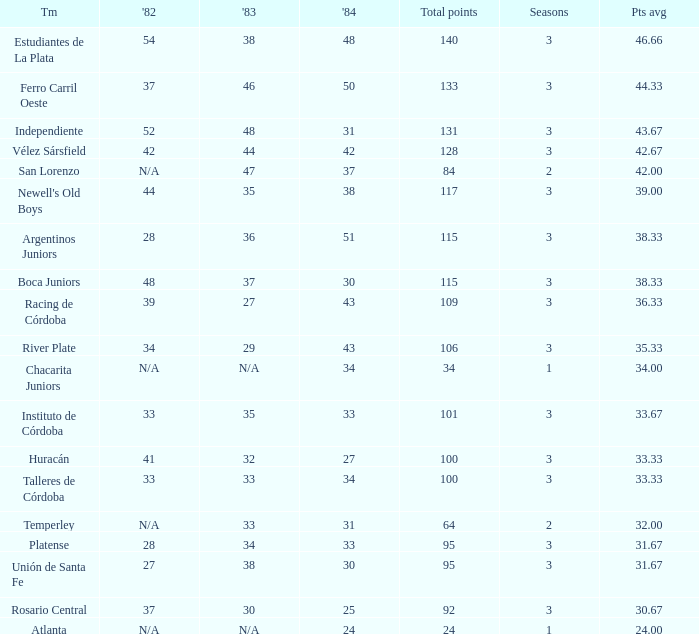What team had 3 seasons and fewer than 27 in 1984? Rosario Central. 